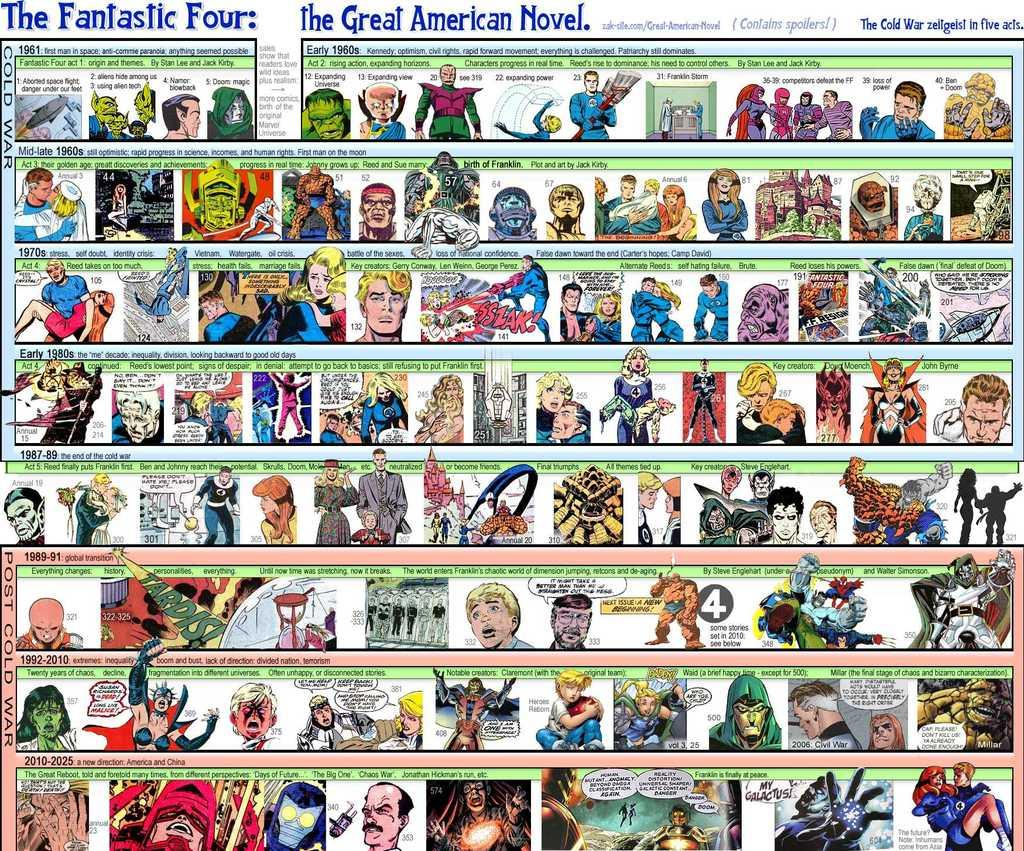What type of images are present in the image? There are cartoon pictures in the image. Can you describe the colors of the cartoon pictures? The cartoon pictures are in multiple colors. Is there any text present in the image? Yes, there is text written on the image. How many times does the comb appear in the image? There is no comb present in the image. What does the mouth of the cartoon character say in the image? There are no cartoon characters with mouths present in the image. 